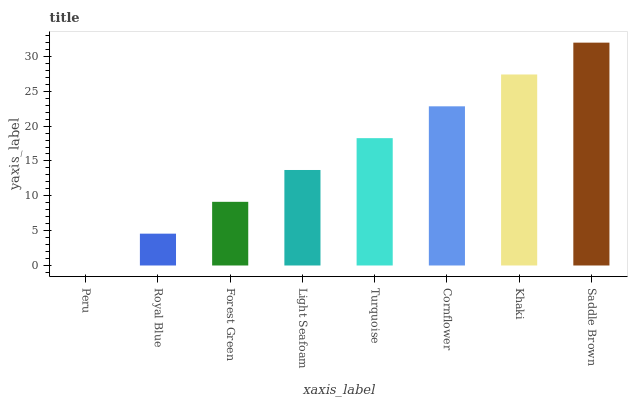Is Peru the minimum?
Answer yes or no. Yes. Is Saddle Brown the maximum?
Answer yes or no. Yes. Is Royal Blue the minimum?
Answer yes or no. No. Is Royal Blue the maximum?
Answer yes or no. No. Is Royal Blue greater than Peru?
Answer yes or no. Yes. Is Peru less than Royal Blue?
Answer yes or no. Yes. Is Peru greater than Royal Blue?
Answer yes or no. No. Is Royal Blue less than Peru?
Answer yes or no. No. Is Turquoise the high median?
Answer yes or no. Yes. Is Light Seafoam the low median?
Answer yes or no. Yes. Is Forest Green the high median?
Answer yes or no. No. Is Royal Blue the low median?
Answer yes or no. No. 